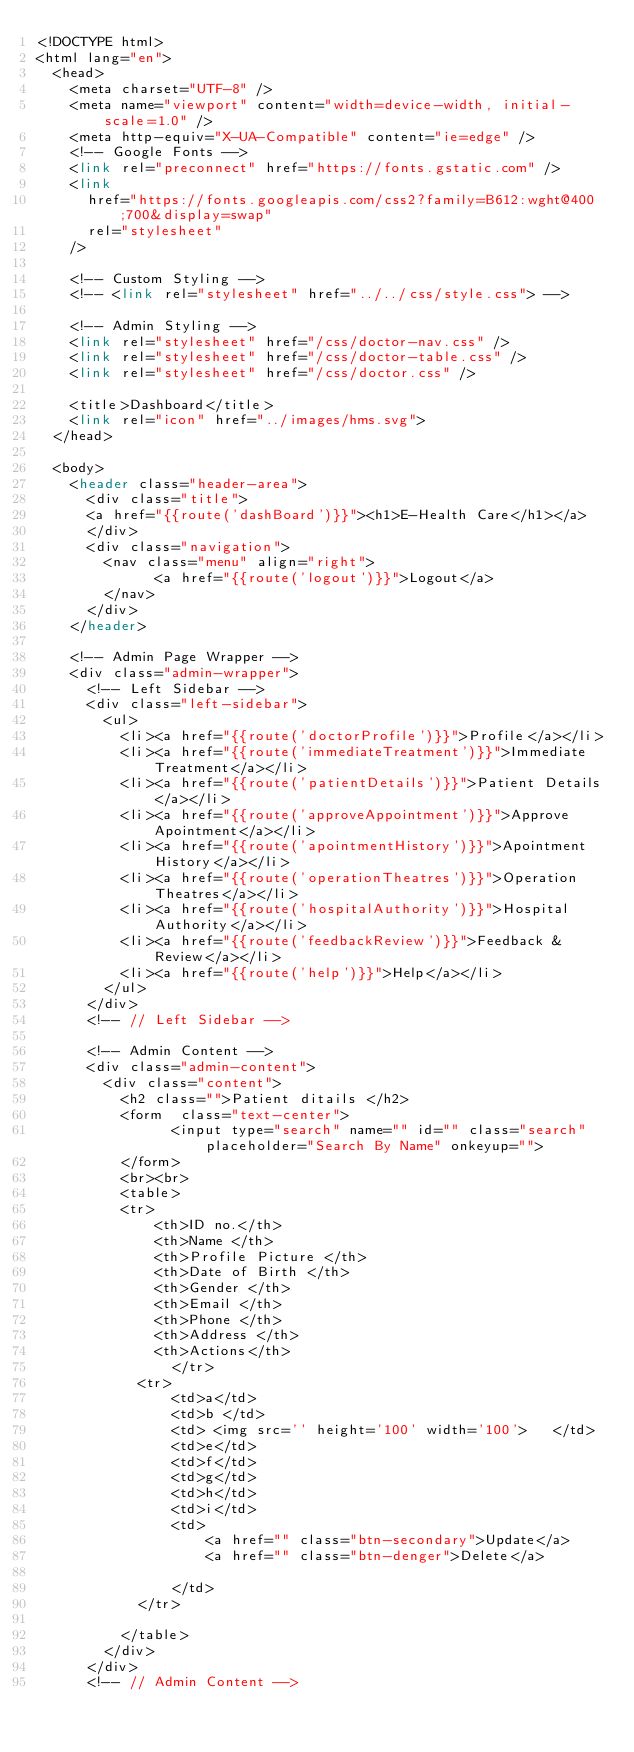Convert code to text. <code><loc_0><loc_0><loc_500><loc_500><_PHP_><!DOCTYPE html>
<html lang="en">
  <head>
    <meta charset="UTF-8" />
    <meta name="viewport" content="width=device-width, initial-scale=1.0" />
    <meta http-equiv="X-UA-Compatible" content="ie=edge" />
    <!-- Google Fonts -->
    <link rel="preconnect" href="https://fonts.gstatic.com" />
    <link
      href="https://fonts.googleapis.com/css2?family=B612:wght@400;700&display=swap"
      rel="stylesheet"
    />

    <!-- Custom Styling -->
    <!-- <link rel="stylesheet" href="../../css/style.css"> -->

    <!-- Admin Styling -->
    <link rel="stylesheet" href="/css/doctor-nav.css" />
    <link rel="stylesheet" href="/css/doctor-table.css" />
    <link rel="stylesheet" href="/css/doctor.css" />

    <title>Dashboard</title>
    <link rel="icon" href="../images/hms.svg">
  </head>

  <body>
    <header class="header-area">
      <div class="title">
      <a href="{{route('dashBoard')}}"><h1>E-Health Care</h1></a>
      </div>
      <div class="navigation">
        <nav class="menu" align="right">
              <a href="{{route('logout')}}">Logout</a>
        </nav>
      </div>
    </header>

    <!-- Admin Page Wrapper -->
    <div class="admin-wrapper">
      <!-- Left Sidebar -->
      <div class="left-sidebar">
        <ul>
          <li><a href="{{route('doctorProfile')}}">Profile</a></li>
          <li><a href="{{route('immediateTreatment')}}">Immediate Treatment</a></li>
          <li><a href="{{route('patientDetails')}}">Patient Details</a></li>
          <li><a href="{{route('approveAppointment')}}">Approve Apointment</a></li>
          <li><a href="{{route('apointmentHistory')}}">Apointment History</a></li>
          <li><a href="{{route('operationTheatres')}}">Operation Theatres</a></li>
          <li><a href="{{route('hospitalAuthority')}}">Hospital Authority</a></li>
          <li><a href="{{route('feedbackReview')}}">Feedback & Review</a></li>
          <li><a href="{{route('help')}}">Help</a></li>
        </ul>
      </div>
      <!-- // Left Sidebar -->

      <!-- Admin Content -->
      <div class="admin-content">
        <div class="content">
          <h2 class="">Patient ditails </h2>
          <form  class="text-center">
                <input type="search" name="" id="" class="search" placeholder="Search By Name" onkeyup="">      
          </form>
          <br><br>
          <table>
          <tr>
              <th>ID no.</th>
              <th>Name </th>
              <th>Profile Picture </th>
              <th>Date of Birth </th>
              <th>Gender </th>
              <th>Email </th>
              <th>Phone </th>
              <th>Address </th>
              <th>Actions</th>
		        </tr>
            <tr>
                <td>a</td>
                <td>b </td>
                <td> <img src='' height='100' width='100'>   </td>
                <td>e</td>
                <td>f</td>
                <td>g</td>
                <td>h</td>
                <td>i</td>
                <td>
                    <a href="" class="btn-secondary">Update</a>
                    <a href="" class="btn-denger">Delete</a>
                    
                </td>
            </tr>
          
          </table>
        </div>
      </div>
      <!-- // Admin Content --></code> 